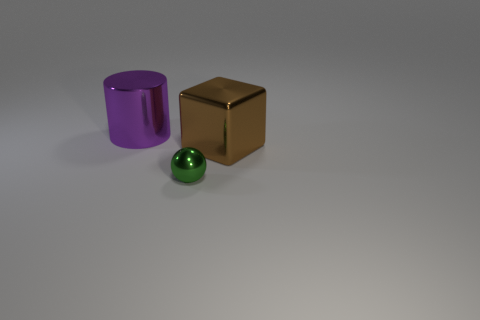Add 2 big brown rubber things. How many objects exist? 5 Subtract all blocks. How many objects are left? 2 Subtract 0 gray blocks. How many objects are left? 3 Subtract all green spheres. Subtract all small metallic things. How many objects are left? 1 Add 3 big cylinders. How many big cylinders are left? 4 Add 3 big green metal blocks. How many big green metal blocks exist? 3 